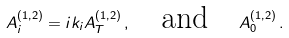<formula> <loc_0><loc_0><loc_500><loc_500>A ^ { ( 1 , 2 ) } _ { i } = i k _ { i } A ^ { ( 1 , 2 ) } _ { T } \, , \quad \text {and} \quad A ^ { ( 1 , 2 ) } _ { 0 } \, .</formula> 